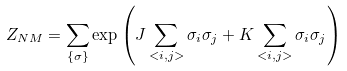Convert formula to latex. <formula><loc_0><loc_0><loc_500><loc_500>Z _ { N M } = \sum _ { \{ \sigma \} } \exp { \left ( J \sum _ { < i , j > } \sigma _ { i } \sigma _ { j } + K \sum _ { < i , j > } \sigma _ { i } \sigma _ { j } \right ) }</formula> 